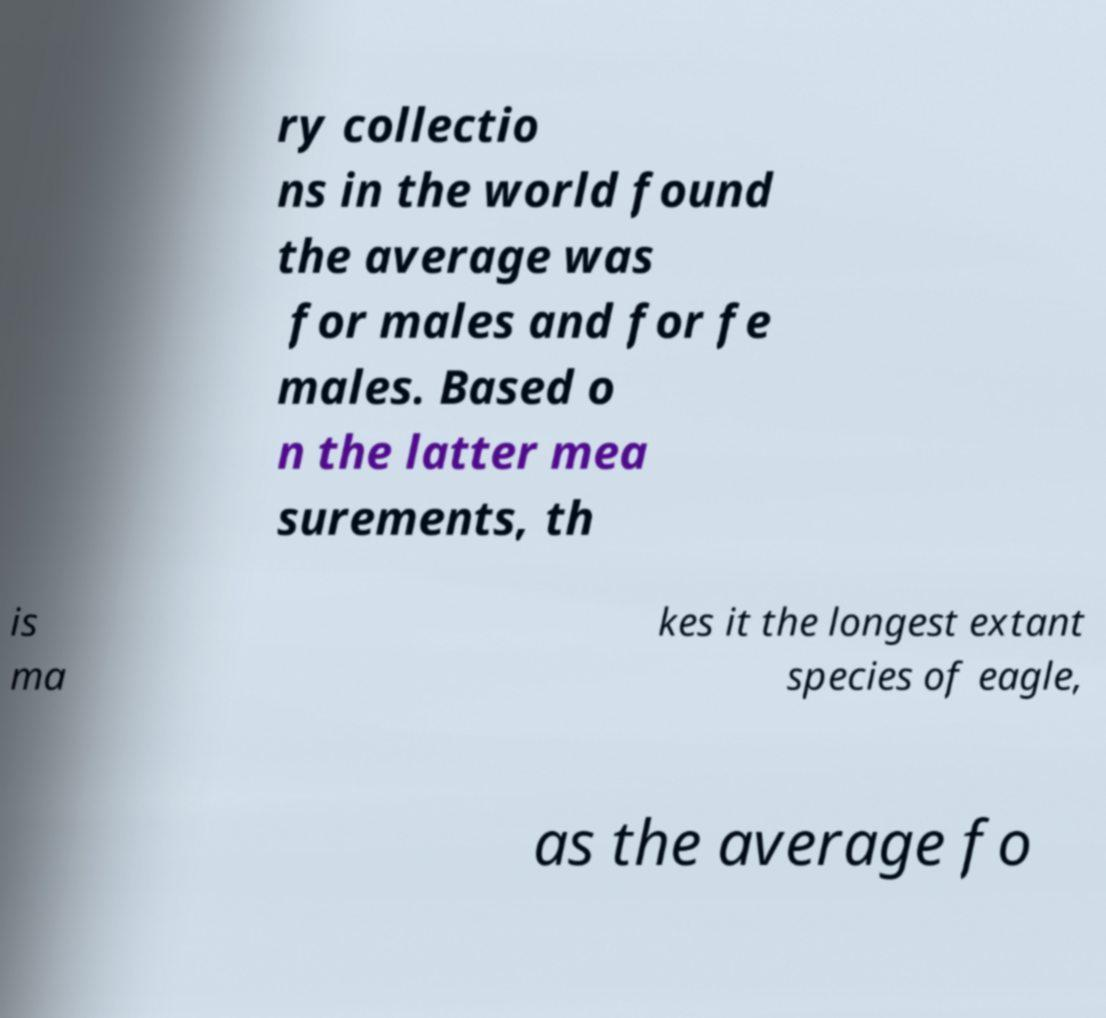I need the written content from this picture converted into text. Can you do that? ry collectio ns in the world found the average was for males and for fe males. Based o n the latter mea surements, th is ma kes it the longest extant species of eagle, as the average fo 